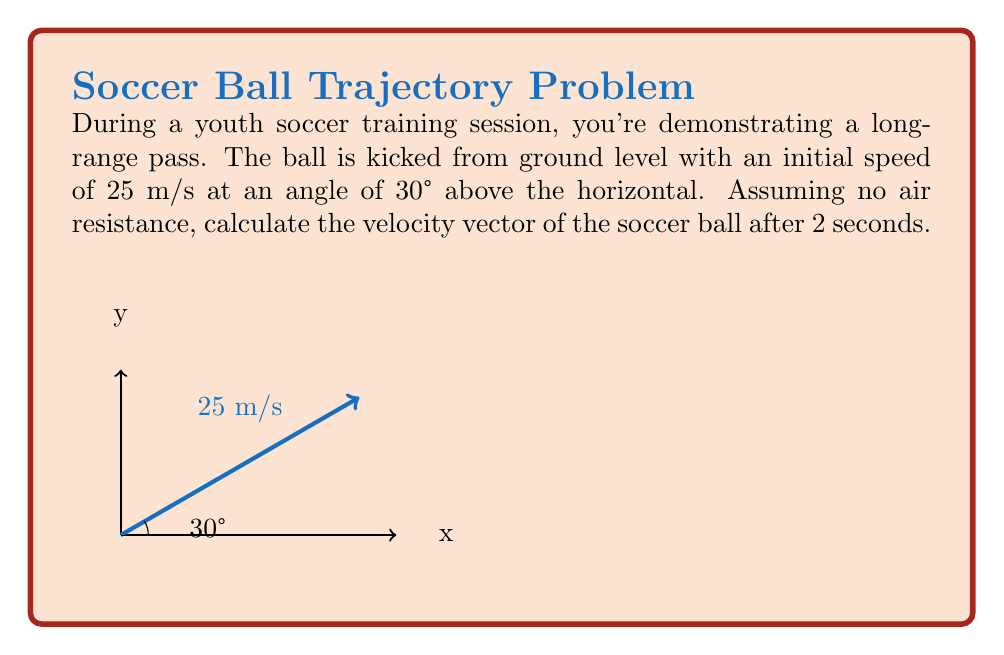What is the answer to this math problem? Let's approach this step-by-step:

1) First, we need to determine the initial velocity components:
   
   Initial velocity in x-direction: $v_{x0} = 25 \cos(30°) = 25 \cdot \frac{\sqrt{3}}{2} = 21.65$ m/s
   Initial velocity in y-direction: $v_{y0} = 25 \sin(30°) = 25 \cdot \frac{1}{2} = 12.5$ m/s

2) Now, we can use the equations of motion:
   
   $v_x = v_{x0}$ (constant as there's no acceleration in x-direction)
   $v_y = v_{y0} - gt$ (where $g = 9.8$ m/s², t = 2s)

3) Calculate $v_y$ after 2 seconds:
   
   $v_y = 12.5 - 9.8 \cdot 2 = 12.5 - 19.6 = -7.1$ m/s

4) Now we have both components of the velocity vector after 2 seconds:
   
   $\vec{v} = (21.65, -7.1)$ m/s

5) To express this as a single vector:
   
   $\vec{v} = 21.65\hat{i} - 7.1\hat{j}$ m/s

Where $\hat{i}$ and $\hat{j}$ are unit vectors in the x and y directions respectively.
Answer: $\vec{v} = 21.65\hat{i} - 7.1\hat{j}$ m/s 